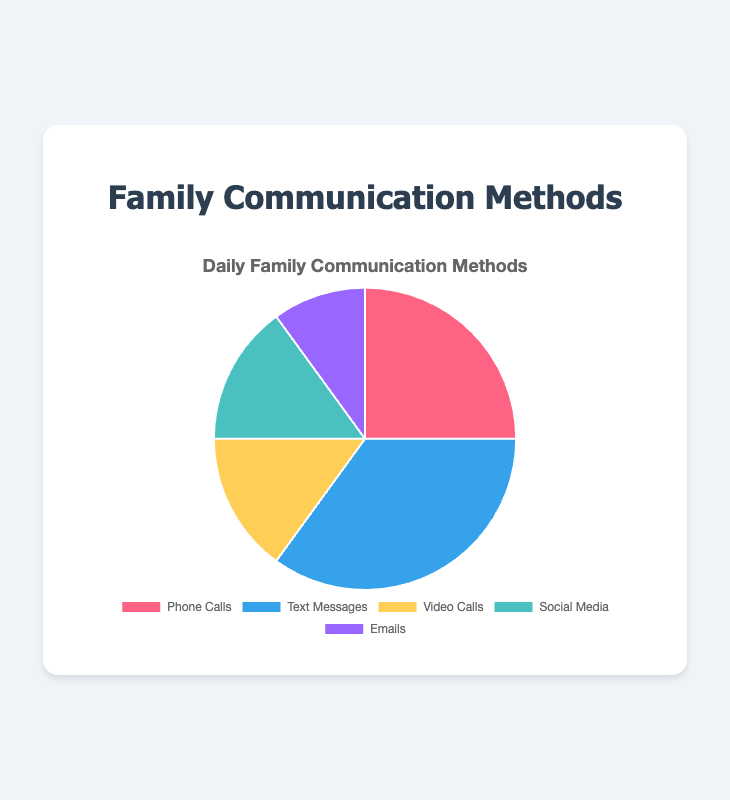What's the most frequently used method of communication? The chart shows the distribution of communication methods used. The segment with the largest portion represents the most frequently used method. In this case, Text Messages hold the largest portion.
Answer: Text Messages Which methods of communication share the same percentage usage? By examining the chart, you can observe that Video Calls and Social Media have the same segment size, indicating they have the same percentage usage. Both are used 15% of the time.
Answer: Video Calls, Social Media What percentage of communication methods are Phone Calls and Emails combined? To find the combined percentage of Phone Calls and Emails, sum their individual percentages. Phone Calls are 25% and Emails are 10%, thus combined they are 25% + 10%.
Answer: 35% Which communication method is used the least? The smallest segment in the chart represents the least used communication method. From the chart, it is visible that Emails are the least used method, making up 10%.
Answer: Emails How does the usage of Text Messages compare to that of Social Media? The segment for Text Messages is larger than that for Social Media, indicating higher usage. In percentage terms, Text Messages are 35% and Social Media is 15%.
Answer: More Are Video Calls and Emails together used more or less than Phone Calls? Calculate the combined percentage of Video Calls and Emails: 15% (Video Calls) + 10% (Emails) = 25%. This matches the percentage of Phone Calls, which is also 25%.
Answer: Equal If Text Messages and Social Media are grouped together as digital communications, what percentage do they account for? Combine the percentages of Text Messages and Social Media: 35% (Text Messages) + 15% (Social Media) = 50%.
Answer: 50% What methods make up at least 15% of the communication methods each? By examining the segment sizes, the methods that each account for at least 15% are: Phone Calls (25%), Text Messages (35%), Video Calls (15%), and Social Media (15%).
Answer: Phone Calls, Text Messages, Video Calls, Social Media 